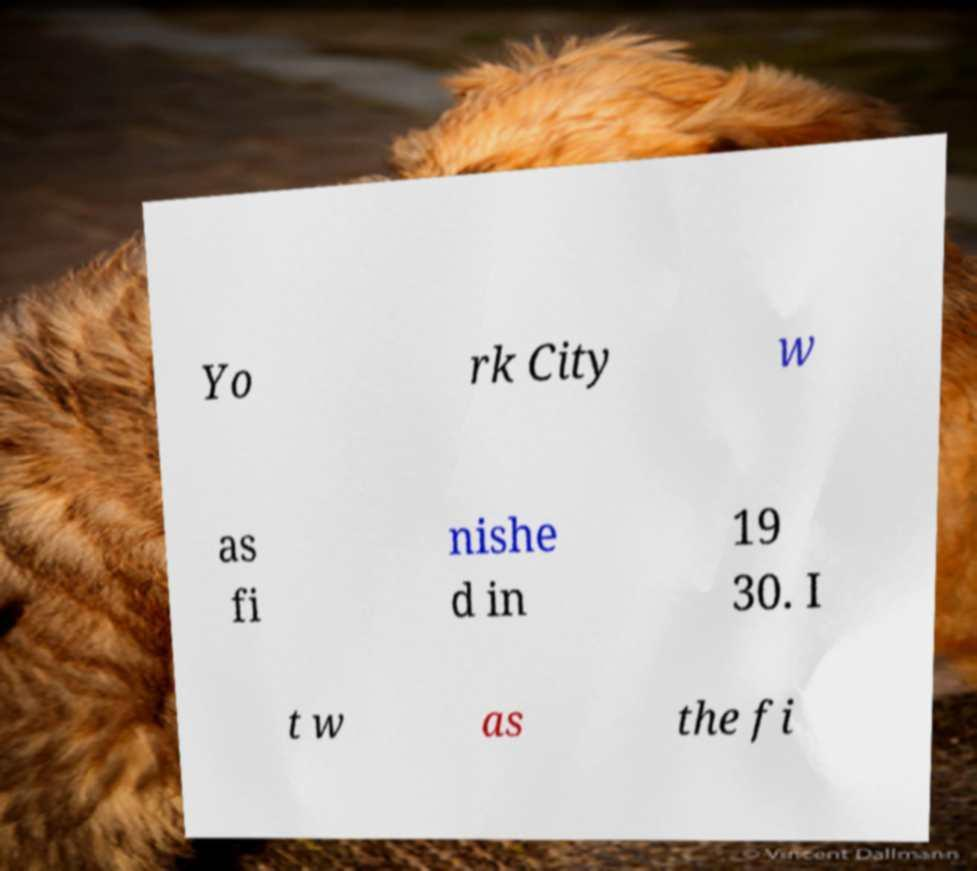Can you accurately transcribe the text from the provided image for me? Yo rk City w as fi nishe d in 19 30. I t w as the fi 